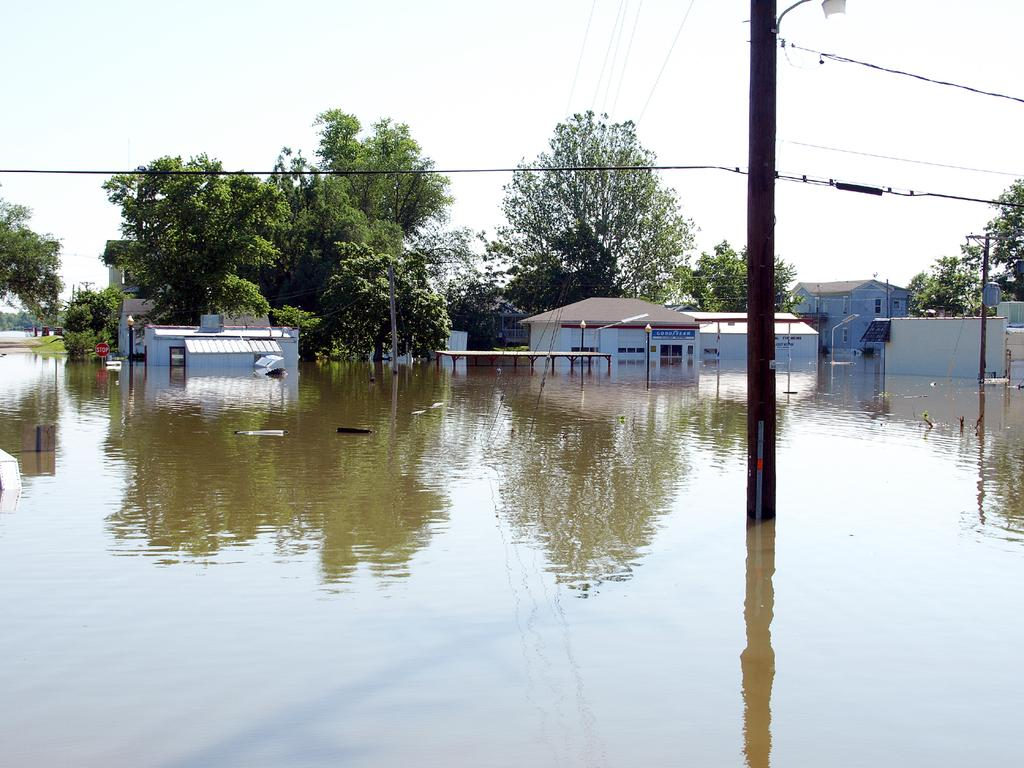What is the primary element visible in the image? There is water in the image. What structures can be seen near the water? There are electric poles in the image. What can be seen in the distance behind the water? There are buildings and trees in the background of the image. What color are the buildings in the image? The buildings are white in color. What color are the trees in the image? The trees are green in color. What else is visible in the background of the image? The sky is visible in the background of the image and is white in color. What type of vessel is being developed in the image? There is no vessel being developed in the image; it primarily features water, electric poles, buildings, trees, and the sky. 